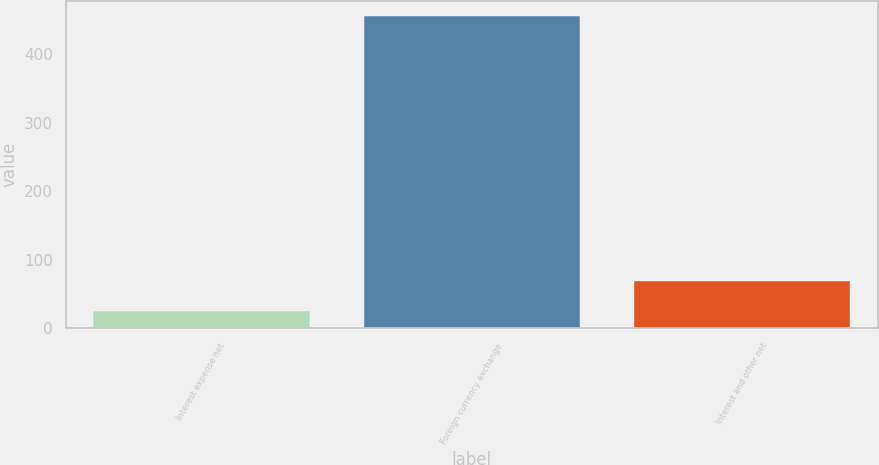Convert chart. <chart><loc_0><loc_0><loc_500><loc_500><bar_chart><fcel>Interest expense net<fcel>Foreign currency exchange<fcel>Interest and other net<nl><fcel>25.8<fcel>454.7<fcel>68.69<nl></chart> 